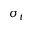Convert formula to latex. <formula><loc_0><loc_0><loc_500><loc_500>\sigma _ { t }</formula> 